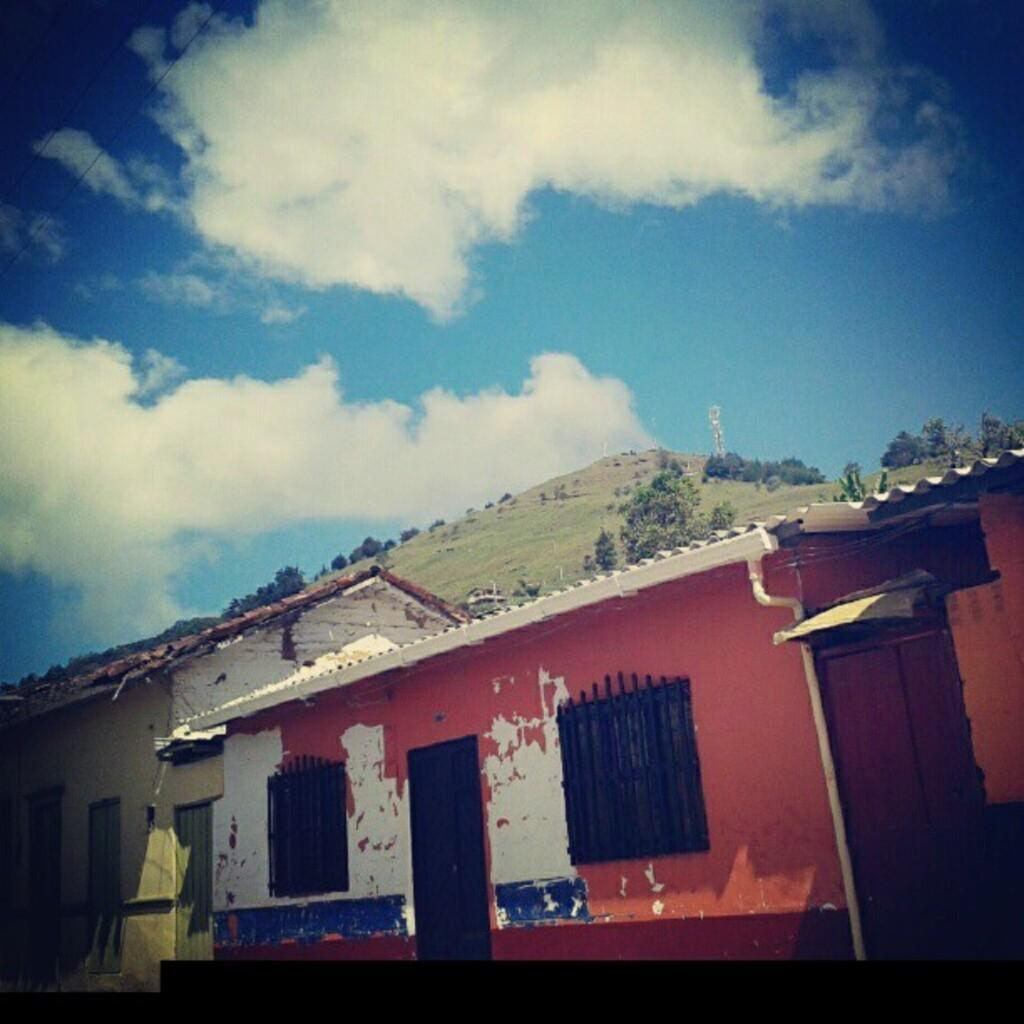How many houses can be seen in the image? There are two houses in the image. What is located behind the houses? There are trees behind the houses. What geographical feature is visible in the image? There is a mountain visible in the image. What is the condition of the sky in the image? The sky is clouded in the image. How many bananas are hanging from the trees behind the houses? There are no bananas visible in the image; only trees are present. Are the sisters in the image holding butter while standing next to the mountain? There is no mention of sisters or butter in the image; it only features two houses, trees, a mountain, and a clouded sky. 